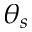<formula> <loc_0><loc_0><loc_500><loc_500>\theta _ { s }</formula> 